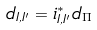Convert formula to latex. <formula><loc_0><loc_0><loc_500><loc_500>d _ { I , I ^ { \prime } } = i ^ { * } _ { I , I ^ { \prime } } d _ { \Pi }</formula> 